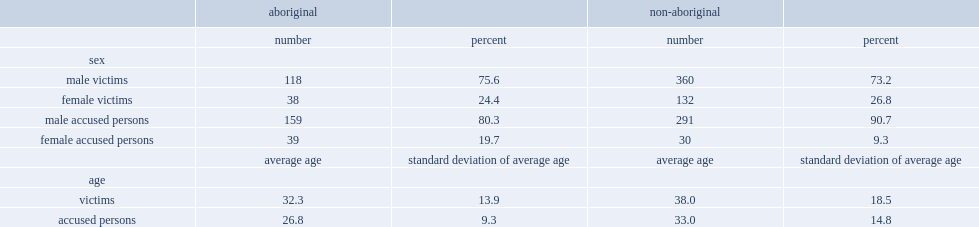What was the average age for non-aboriginal victims? 38.0. What was the average age for aboriginal victims? 32.3. What was the average age for aboriginal accused persons? 26.8. What was the average age for non-aboriginal accused persons? 33.0. 